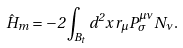<formula> <loc_0><loc_0><loc_500><loc_500>\hat { H } _ { m } = - 2 \int _ { B _ { t } } d ^ { 2 } x \, r _ { \mu } P _ { \sigma } ^ { \mu \nu } N _ { \nu } .</formula> 